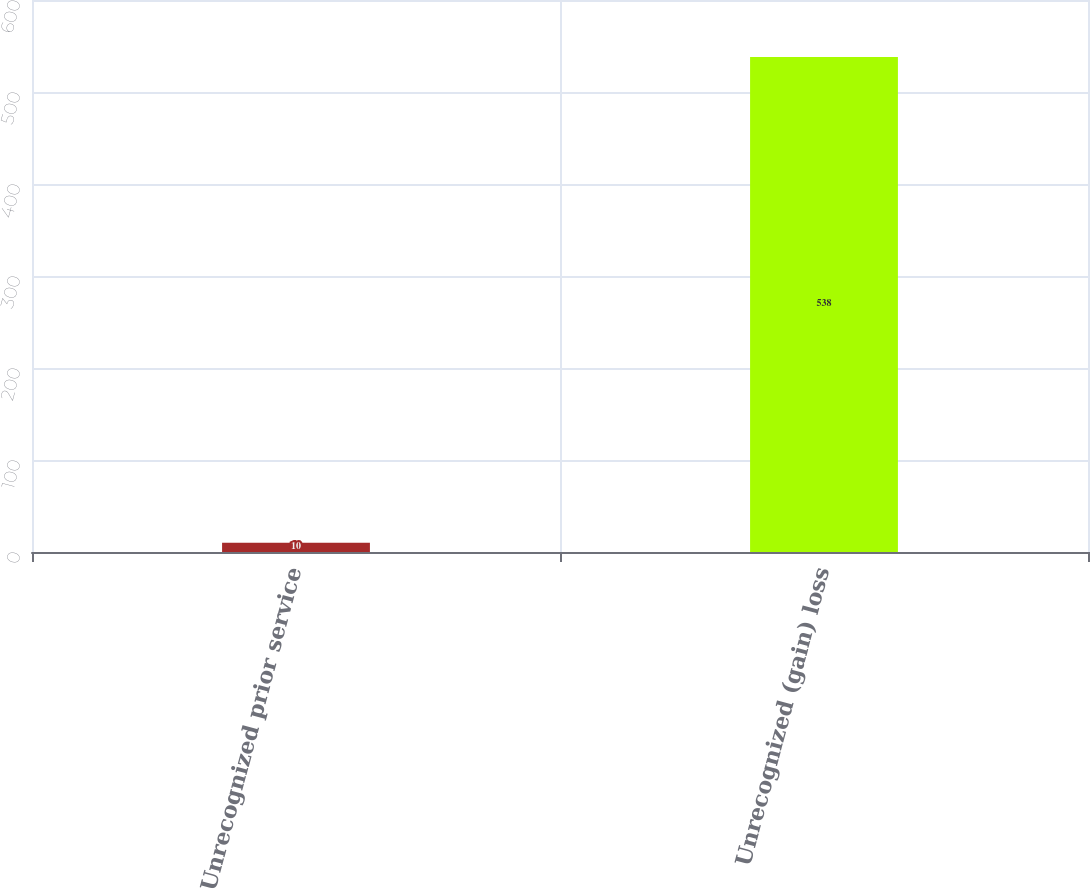<chart> <loc_0><loc_0><loc_500><loc_500><bar_chart><fcel>Unrecognized prior service<fcel>Unrecognized (gain) loss<nl><fcel>10<fcel>538<nl></chart> 